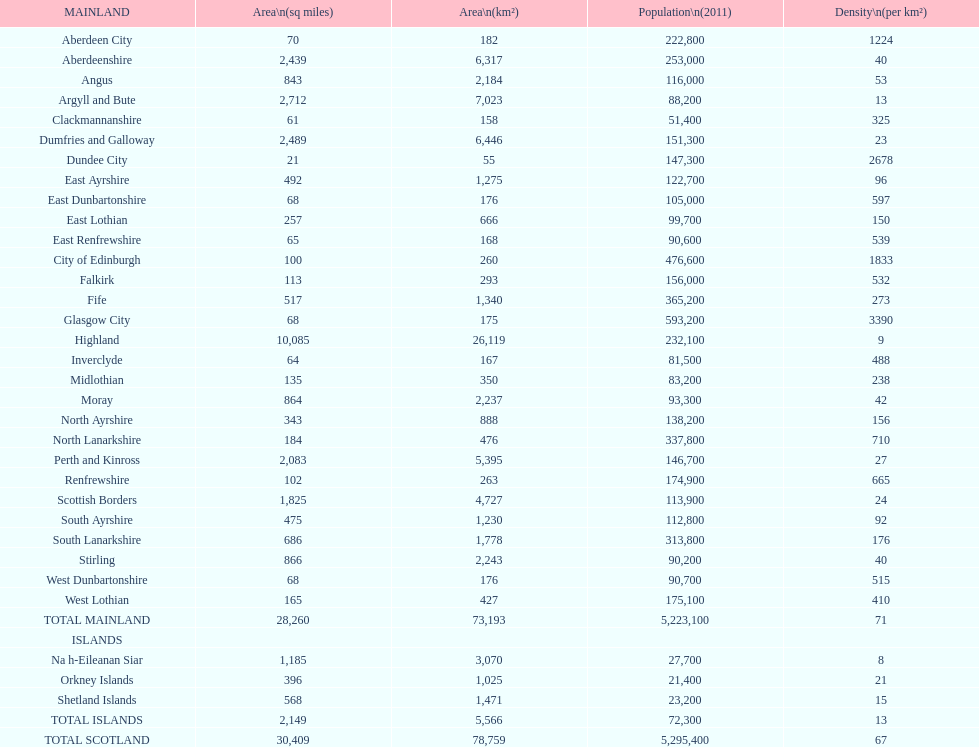What is the number of people living in angus in 2011? 116,000. 